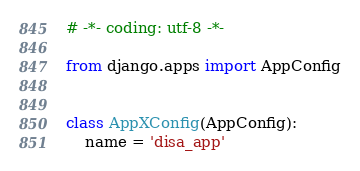<code> <loc_0><loc_0><loc_500><loc_500><_Python_># -*- coding: utf-8 -*-

from django.apps import AppConfig


class AppXConfig(AppConfig):
    name = 'disa_app'
</code> 